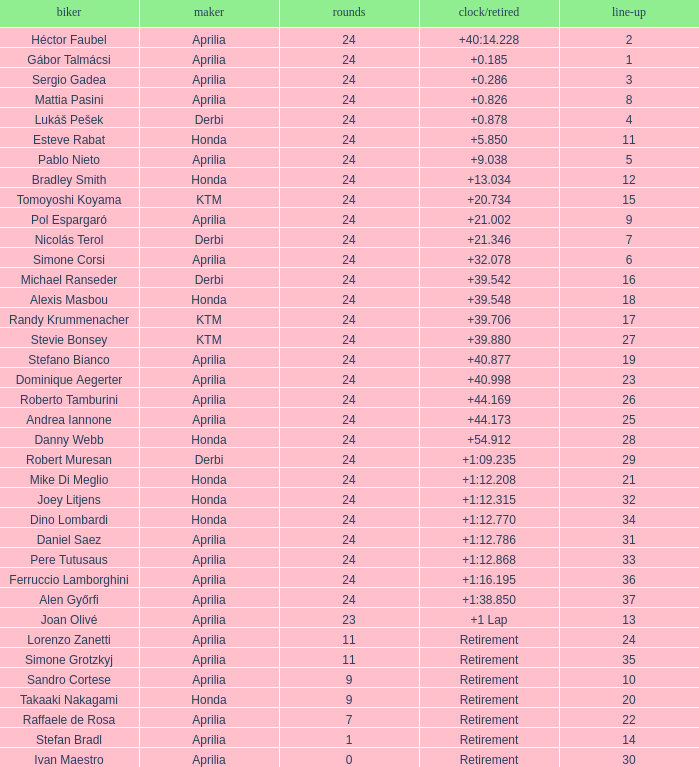Who produced the motorcycle that completed 24 laps and 9 grids? Aprilia. 